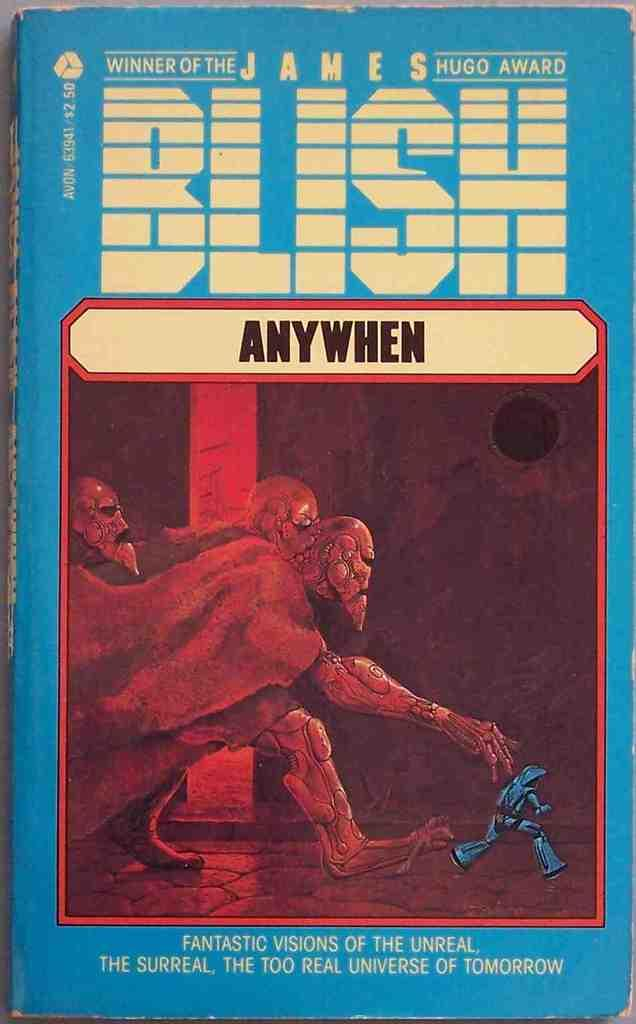What is the main subject of the image? The main subject of the image is the cover page of a book. What type of images are on the cover page? The cover page contains animated images. Is there any text on the cover page? Yes, there is text on the cover page. What type of rake is shown on the cover page? There is no rake present on the cover page; it features animated images and text. How does the liquid flow on the cover page? There is no liquid present on the cover page; it contains animated images and text. 